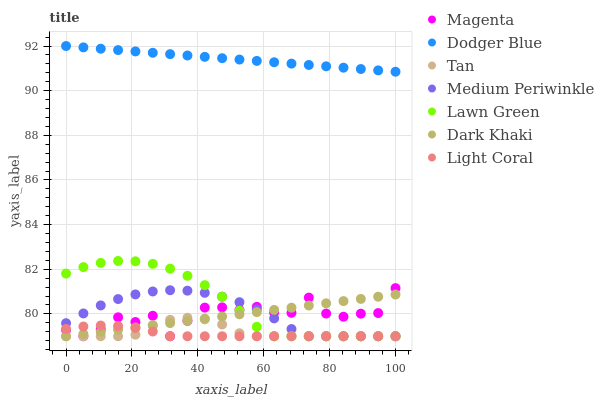Does Light Coral have the minimum area under the curve?
Answer yes or no. Yes. Does Dodger Blue have the maximum area under the curve?
Answer yes or no. Yes. Does Medium Periwinkle have the minimum area under the curve?
Answer yes or no. No. Does Medium Periwinkle have the maximum area under the curve?
Answer yes or no. No. Is Dark Khaki the smoothest?
Answer yes or no. Yes. Is Magenta the roughest?
Answer yes or no. Yes. Is Medium Periwinkle the smoothest?
Answer yes or no. No. Is Medium Periwinkle the roughest?
Answer yes or no. No. Does Lawn Green have the lowest value?
Answer yes or no. Yes. Does Dodger Blue have the lowest value?
Answer yes or no. No. Does Dodger Blue have the highest value?
Answer yes or no. Yes. Does Medium Periwinkle have the highest value?
Answer yes or no. No. Is Magenta less than Dodger Blue?
Answer yes or no. Yes. Is Dodger Blue greater than Tan?
Answer yes or no. Yes. Does Light Coral intersect Tan?
Answer yes or no. Yes. Is Light Coral less than Tan?
Answer yes or no. No. Is Light Coral greater than Tan?
Answer yes or no. No. Does Magenta intersect Dodger Blue?
Answer yes or no. No. 